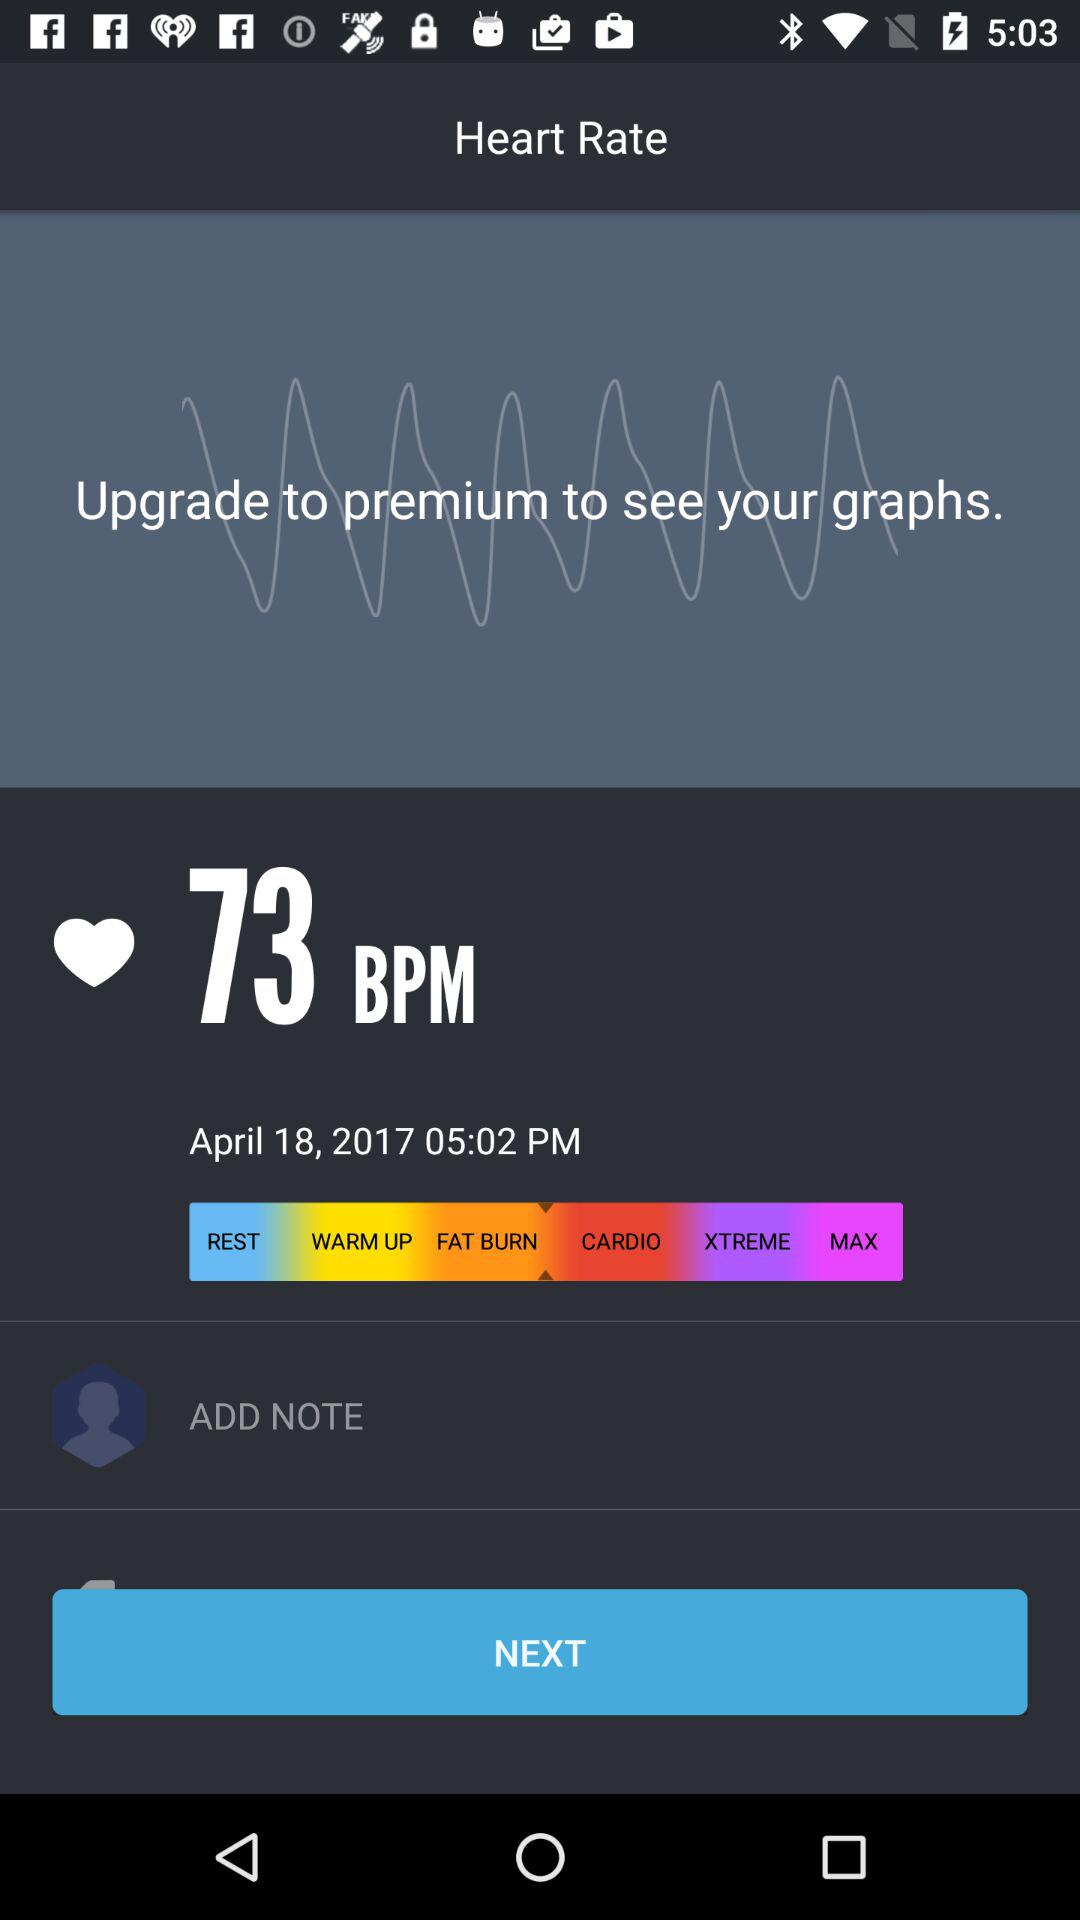What is the application name?
When the provided information is insufficient, respond with <no answer>. <no answer> 